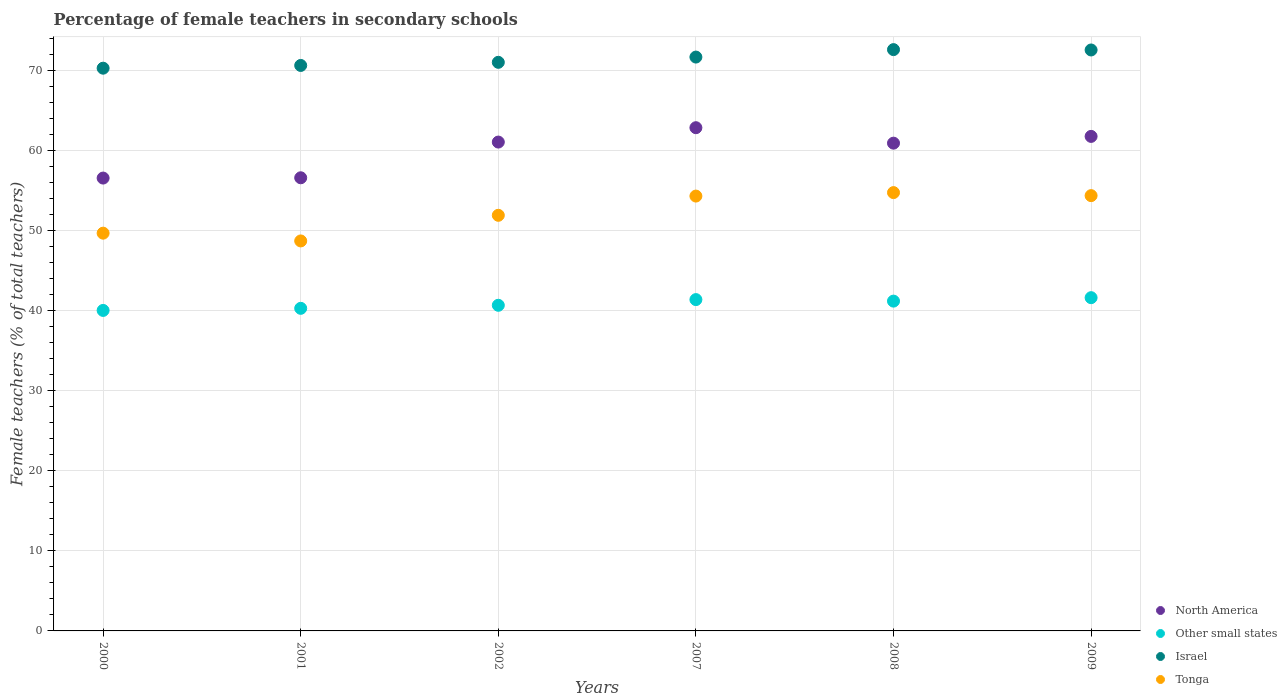How many different coloured dotlines are there?
Make the answer very short. 4. What is the percentage of female teachers in Israel in 2007?
Your response must be concise. 71.63. Across all years, what is the maximum percentage of female teachers in North America?
Give a very brief answer. 62.81. Across all years, what is the minimum percentage of female teachers in Tonga?
Your answer should be compact. 48.68. What is the total percentage of female teachers in Tonga in the graph?
Provide a short and direct response. 313.52. What is the difference between the percentage of female teachers in North America in 2008 and that in 2009?
Offer a very short reply. -0.84. What is the difference between the percentage of female teachers in Other small states in 2007 and the percentage of female teachers in North America in 2008?
Provide a short and direct response. -19.53. What is the average percentage of female teachers in Israel per year?
Offer a terse response. 71.42. In the year 2002, what is the difference between the percentage of female teachers in North America and percentage of female teachers in Tonga?
Your answer should be very brief. 9.14. In how many years, is the percentage of female teachers in North America greater than 52 %?
Give a very brief answer. 6. What is the ratio of the percentage of female teachers in Tonga in 2000 to that in 2008?
Ensure brevity in your answer.  0.91. What is the difference between the highest and the second highest percentage of female teachers in Other small states?
Provide a succinct answer. 0.24. What is the difference between the highest and the lowest percentage of female teachers in North America?
Provide a succinct answer. 6.29. Is the sum of the percentage of female teachers in North America in 2007 and 2008 greater than the maximum percentage of female teachers in Israel across all years?
Your response must be concise. Yes. How many years are there in the graph?
Your answer should be compact. 6. What is the difference between two consecutive major ticks on the Y-axis?
Give a very brief answer. 10. Does the graph contain any zero values?
Ensure brevity in your answer.  No. Where does the legend appear in the graph?
Offer a terse response. Bottom right. How many legend labels are there?
Give a very brief answer. 4. How are the legend labels stacked?
Ensure brevity in your answer.  Vertical. What is the title of the graph?
Offer a very short reply. Percentage of female teachers in secondary schools. What is the label or title of the X-axis?
Give a very brief answer. Years. What is the label or title of the Y-axis?
Give a very brief answer. Female teachers (% of total teachers). What is the Female teachers (% of total teachers) in North America in 2000?
Offer a terse response. 56.52. What is the Female teachers (% of total teachers) in Other small states in 2000?
Make the answer very short. 40. What is the Female teachers (% of total teachers) of Israel in 2000?
Ensure brevity in your answer.  70.24. What is the Female teachers (% of total teachers) in Tonga in 2000?
Give a very brief answer. 49.65. What is the Female teachers (% of total teachers) in North America in 2001?
Keep it short and to the point. 56.56. What is the Female teachers (% of total teachers) of Other small states in 2001?
Your answer should be very brief. 40.27. What is the Female teachers (% of total teachers) in Israel in 2001?
Your response must be concise. 70.58. What is the Female teachers (% of total teachers) of Tonga in 2001?
Offer a terse response. 48.68. What is the Female teachers (% of total teachers) of North America in 2002?
Give a very brief answer. 61.02. What is the Female teachers (% of total teachers) in Other small states in 2002?
Keep it short and to the point. 40.65. What is the Female teachers (% of total teachers) of Israel in 2002?
Your answer should be very brief. 70.97. What is the Female teachers (% of total teachers) in Tonga in 2002?
Your response must be concise. 51.88. What is the Female teachers (% of total teachers) in North America in 2007?
Keep it short and to the point. 62.81. What is the Female teachers (% of total teachers) of Other small states in 2007?
Your answer should be compact. 41.36. What is the Female teachers (% of total teachers) of Israel in 2007?
Keep it short and to the point. 71.63. What is the Female teachers (% of total teachers) in Tonga in 2007?
Ensure brevity in your answer.  54.28. What is the Female teachers (% of total teachers) in North America in 2008?
Your response must be concise. 60.88. What is the Female teachers (% of total teachers) of Other small states in 2008?
Keep it short and to the point. 41.17. What is the Female teachers (% of total teachers) of Israel in 2008?
Provide a short and direct response. 72.56. What is the Female teachers (% of total teachers) of Tonga in 2008?
Keep it short and to the point. 54.71. What is the Female teachers (% of total teachers) of North America in 2009?
Offer a very short reply. 61.73. What is the Female teachers (% of total teachers) in Other small states in 2009?
Offer a terse response. 41.6. What is the Female teachers (% of total teachers) of Israel in 2009?
Your answer should be very brief. 72.51. What is the Female teachers (% of total teachers) of Tonga in 2009?
Your response must be concise. 54.33. Across all years, what is the maximum Female teachers (% of total teachers) of North America?
Provide a short and direct response. 62.81. Across all years, what is the maximum Female teachers (% of total teachers) in Other small states?
Make the answer very short. 41.6. Across all years, what is the maximum Female teachers (% of total teachers) in Israel?
Provide a short and direct response. 72.56. Across all years, what is the maximum Female teachers (% of total teachers) in Tonga?
Your response must be concise. 54.71. Across all years, what is the minimum Female teachers (% of total teachers) in North America?
Offer a very short reply. 56.52. Across all years, what is the minimum Female teachers (% of total teachers) in Other small states?
Provide a succinct answer. 40. Across all years, what is the minimum Female teachers (% of total teachers) of Israel?
Provide a short and direct response. 70.24. Across all years, what is the minimum Female teachers (% of total teachers) of Tonga?
Offer a very short reply. 48.68. What is the total Female teachers (% of total teachers) in North America in the graph?
Your answer should be compact. 359.53. What is the total Female teachers (% of total teachers) of Other small states in the graph?
Ensure brevity in your answer.  245.03. What is the total Female teachers (% of total teachers) in Israel in the graph?
Your answer should be compact. 428.49. What is the total Female teachers (% of total teachers) of Tonga in the graph?
Ensure brevity in your answer.  313.52. What is the difference between the Female teachers (% of total teachers) in North America in 2000 and that in 2001?
Make the answer very short. -0.04. What is the difference between the Female teachers (% of total teachers) of Other small states in 2000 and that in 2001?
Give a very brief answer. -0.26. What is the difference between the Female teachers (% of total teachers) of Israel in 2000 and that in 2001?
Your answer should be compact. -0.34. What is the difference between the Female teachers (% of total teachers) in Tonga in 2000 and that in 2001?
Your response must be concise. 0.97. What is the difference between the Female teachers (% of total teachers) of North America in 2000 and that in 2002?
Provide a short and direct response. -4.49. What is the difference between the Female teachers (% of total teachers) of Other small states in 2000 and that in 2002?
Your answer should be compact. -0.64. What is the difference between the Female teachers (% of total teachers) in Israel in 2000 and that in 2002?
Ensure brevity in your answer.  -0.73. What is the difference between the Female teachers (% of total teachers) in Tonga in 2000 and that in 2002?
Make the answer very short. -2.23. What is the difference between the Female teachers (% of total teachers) in North America in 2000 and that in 2007?
Offer a very short reply. -6.29. What is the difference between the Female teachers (% of total teachers) in Other small states in 2000 and that in 2007?
Ensure brevity in your answer.  -1.35. What is the difference between the Female teachers (% of total teachers) of Israel in 2000 and that in 2007?
Ensure brevity in your answer.  -1.39. What is the difference between the Female teachers (% of total teachers) of Tonga in 2000 and that in 2007?
Ensure brevity in your answer.  -4.63. What is the difference between the Female teachers (% of total teachers) of North America in 2000 and that in 2008?
Give a very brief answer. -4.36. What is the difference between the Female teachers (% of total teachers) in Other small states in 2000 and that in 2008?
Offer a terse response. -1.16. What is the difference between the Female teachers (% of total teachers) in Israel in 2000 and that in 2008?
Keep it short and to the point. -2.32. What is the difference between the Female teachers (% of total teachers) in Tonga in 2000 and that in 2008?
Offer a terse response. -5.06. What is the difference between the Female teachers (% of total teachers) in North America in 2000 and that in 2009?
Offer a very short reply. -5.2. What is the difference between the Female teachers (% of total teachers) of Other small states in 2000 and that in 2009?
Offer a very short reply. -1.59. What is the difference between the Female teachers (% of total teachers) of Israel in 2000 and that in 2009?
Offer a very short reply. -2.27. What is the difference between the Female teachers (% of total teachers) in Tonga in 2000 and that in 2009?
Keep it short and to the point. -4.68. What is the difference between the Female teachers (% of total teachers) in North America in 2001 and that in 2002?
Provide a succinct answer. -4.46. What is the difference between the Female teachers (% of total teachers) in Other small states in 2001 and that in 2002?
Keep it short and to the point. -0.38. What is the difference between the Female teachers (% of total teachers) of Israel in 2001 and that in 2002?
Your answer should be very brief. -0.39. What is the difference between the Female teachers (% of total teachers) in Tonga in 2001 and that in 2002?
Provide a short and direct response. -3.2. What is the difference between the Female teachers (% of total teachers) of North America in 2001 and that in 2007?
Keep it short and to the point. -6.25. What is the difference between the Female teachers (% of total teachers) in Other small states in 2001 and that in 2007?
Ensure brevity in your answer.  -1.09. What is the difference between the Female teachers (% of total teachers) of Israel in 2001 and that in 2007?
Keep it short and to the point. -1.05. What is the difference between the Female teachers (% of total teachers) in Tonga in 2001 and that in 2007?
Provide a succinct answer. -5.6. What is the difference between the Female teachers (% of total teachers) in North America in 2001 and that in 2008?
Your answer should be compact. -4.32. What is the difference between the Female teachers (% of total teachers) in Other small states in 2001 and that in 2008?
Provide a short and direct response. -0.9. What is the difference between the Female teachers (% of total teachers) of Israel in 2001 and that in 2008?
Provide a short and direct response. -1.98. What is the difference between the Female teachers (% of total teachers) of Tonga in 2001 and that in 2008?
Give a very brief answer. -6.03. What is the difference between the Female teachers (% of total teachers) in North America in 2001 and that in 2009?
Give a very brief answer. -5.17. What is the difference between the Female teachers (% of total teachers) in Other small states in 2001 and that in 2009?
Provide a succinct answer. -1.33. What is the difference between the Female teachers (% of total teachers) of Israel in 2001 and that in 2009?
Offer a terse response. -1.93. What is the difference between the Female teachers (% of total teachers) in Tonga in 2001 and that in 2009?
Your answer should be compact. -5.65. What is the difference between the Female teachers (% of total teachers) in North America in 2002 and that in 2007?
Your response must be concise. -1.79. What is the difference between the Female teachers (% of total teachers) in Other small states in 2002 and that in 2007?
Ensure brevity in your answer.  -0.71. What is the difference between the Female teachers (% of total teachers) of Israel in 2002 and that in 2007?
Your answer should be very brief. -0.66. What is the difference between the Female teachers (% of total teachers) in Tonga in 2002 and that in 2007?
Your answer should be very brief. -2.4. What is the difference between the Female teachers (% of total teachers) of North America in 2002 and that in 2008?
Offer a very short reply. 0.14. What is the difference between the Female teachers (% of total teachers) of Other small states in 2002 and that in 2008?
Your answer should be compact. -0.52. What is the difference between the Female teachers (% of total teachers) of Israel in 2002 and that in 2008?
Offer a terse response. -1.59. What is the difference between the Female teachers (% of total teachers) of Tonga in 2002 and that in 2008?
Offer a very short reply. -2.83. What is the difference between the Female teachers (% of total teachers) of North America in 2002 and that in 2009?
Your answer should be compact. -0.71. What is the difference between the Female teachers (% of total teachers) in Other small states in 2002 and that in 2009?
Make the answer very short. -0.95. What is the difference between the Female teachers (% of total teachers) in Israel in 2002 and that in 2009?
Make the answer very short. -1.54. What is the difference between the Female teachers (% of total teachers) of Tonga in 2002 and that in 2009?
Make the answer very short. -2.45. What is the difference between the Female teachers (% of total teachers) of North America in 2007 and that in 2008?
Make the answer very short. 1.93. What is the difference between the Female teachers (% of total teachers) of Other small states in 2007 and that in 2008?
Ensure brevity in your answer.  0.19. What is the difference between the Female teachers (% of total teachers) of Israel in 2007 and that in 2008?
Make the answer very short. -0.93. What is the difference between the Female teachers (% of total teachers) in Tonga in 2007 and that in 2008?
Your answer should be compact. -0.43. What is the difference between the Female teachers (% of total teachers) of North America in 2007 and that in 2009?
Make the answer very short. 1.09. What is the difference between the Female teachers (% of total teachers) in Other small states in 2007 and that in 2009?
Ensure brevity in your answer.  -0.24. What is the difference between the Female teachers (% of total teachers) in Israel in 2007 and that in 2009?
Keep it short and to the point. -0.89. What is the difference between the Female teachers (% of total teachers) in Tonga in 2007 and that in 2009?
Offer a terse response. -0.06. What is the difference between the Female teachers (% of total teachers) of North America in 2008 and that in 2009?
Give a very brief answer. -0.84. What is the difference between the Female teachers (% of total teachers) of Other small states in 2008 and that in 2009?
Make the answer very short. -0.43. What is the difference between the Female teachers (% of total teachers) of Israel in 2008 and that in 2009?
Offer a very short reply. 0.04. What is the difference between the Female teachers (% of total teachers) of Tonga in 2008 and that in 2009?
Your response must be concise. 0.38. What is the difference between the Female teachers (% of total teachers) in North America in 2000 and the Female teachers (% of total teachers) in Other small states in 2001?
Offer a terse response. 16.26. What is the difference between the Female teachers (% of total teachers) of North America in 2000 and the Female teachers (% of total teachers) of Israel in 2001?
Offer a very short reply. -14.06. What is the difference between the Female teachers (% of total teachers) of North America in 2000 and the Female teachers (% of total teachers) of Tonga in 2001?
Ensure brevity in your answer.  7.85. What is the difference between the Female teachers (% of total teachers) in Other small states in 2000 and the Female teachers (% of total teachers) in Israel in 2001?
Your response must be concise. -30.58. What is the difference between the Female teachers (% of total teachers) in Other small states in 2000 and the Female teachers (% of total teachers) in Tonga in 2001?
Provide a succinct answer. -8.67. What is the difference between the Female teachers (% of total teachers) of Israel in 2000 and the Female teachers (% of total teachers) of Tonga in 2001?
Offer a very short reply. 21.56. What is the difference between the Female teachers (% of total teachers) in North America in 2000 and the Female teachers (% of total teachers) in Other small states in 2002?
Give a very brief answer. 15.88. What is the difference between the Female teachers (% of total teachers) in North America in 2000 and the Female teachers (% of total teachers) in Israel in 2002?
Offer a very short reply. -14.45. What is the difference between the Female teachers (% of total teachers) in North America in 2000 and the Female teachers (% of total teachers) in Tonga in 2002?
Provide a short and direct response. 4.65. What is the difference between the Female teachers (% of total teachers) in Other small states in 2000 and the Female teachers (% of total teachers) in Israel in 2002?
Offer a terse response. -30.97. What is the difference between the Female teachers (% of total teachers) of Other small states in 2000 and the Female teachers (% of total teachers) of Tonga in 2002?
Make the answer very short. -11.87. What is the difference between the Female teachers (% of total teachers) of Israel in 2000 and the Female teachers (% of total teachers) of Tonga in 2002?
Your answer should be compact. 18.36. What is the difference between the Female teachers (% of total teachers) in North America in 2000 and the Female teachers (% of total teachers) in Other small states in 2007?
Your answer should be very brief. 15.17. What is the difference between the Female teachers (% of total teachers) in North America in 2000 and the Female teachers (% of total teachers) in Israel in 2007?
Offer a terse response. -15.1. What is the difference between the Female teachers (% of total teachers) in North America in 2000 and the Female teachers (% of total teachers) in Tonga in 2007?
Provide a succinct answer. 2.25. What is the difference between the Female teachers (% of total teachers) in Other small states in 2000 and the Female teachers (% of total teachers) in Israel in 2007?
Offer a very short reply. -31.62. What is the difference between the Female teachers (% of total teachers) of Other small states in 2000 and the Female teachers (% of total teachers) of Tonga in 2007?
Provide a short and direct response. -14.27. What is the difference between the Female teachers (% of total teachers) in Israel in 2000 and the Female teachers (% of total teachers) in Tonga in 2007?
Your answer should be very brief. 15.96. What is the difference between the Female teachers (% of total teachers) in North America in 2000 and the Female teachers (% of total teachers) in Other small states in 2008?
Your answer should be very brief. 15.36. What is the difference between the Female teachers (% of total teachers) in North America in 2000 and the Female teachers (% of total teachers) in Israel in 2008?
Keep it short and to the point. -16.03. What is the difference between the Female teachers (% of total teachers) in North America in 2000 and the Female teachers (% of total teachers) in Tonga in 2008?
Your answer should be compact. 1.81. What is the difference between the Female teachers (% of total teachers) of Other small states in 2000 and the Female teachers (% of total teachers) of Israel in 2008?
Give a very brief answer. -32.55. What is the difference between the Female teachers (% of total teachers) of Other small states in 2000 and the Female teachers (% of total teachers) of Tonga in 2008?
Make the answer very short. -14.71. What is the difference between the Female teachers (% of total teachers) of Israel in 2000 and the Female teachers (% of total teachers) of Tonga in 2008?
Provide a succinct answer. 15.53. What is the difference between the Female teachers (% of total teachers) of North America in 2000 and the Female teachers (% of total teachers) of Other small states in 2009?
Ensure brevity in your answer.  14.93. What is the difference between the Female teachers (% of total teachers) in North America in 2000 and the Female teachers (% of total teachers) in Israel in 2009?
Provide a succinct answer. -15.99. What is the difference between the Female teachers (% of total teachers) in North America in 2000 and the Female teachers (% of total teachers) in Tonga in 2009?
Keep it short and to the point. 2.19. What is the difference between the Female teachers (% of total teachers) in Other small states in 2000 and the Female teachers (% of total teachers) in Israel in 2009?
Give a very brief answer. -32.51. What is the difference between the Female teachers (% of total teachers) in Other small states in 2000 and the Female teachers (% of total teachers) in Tonga in 2009?
Offer a terse response. -14.33. What is the difference between the Female teachers (% of total teachers) in Israel in 2000 and the Female teachers (% of total teachers) in Tonga in 2009?
Your answer should be compact. 15.91. What is the difference between the Female teachers (% of total teachers) in North America in 2001 and the Female teachers (% of total teachers) in Other small states in 2002?
Your answer should be very brief. 15.92. What is the difference between the Female teachers (% of total teachers) of North America in 2001 and the Female teachers (% of total teachers) of Israel in 2002?
Offer a very short reply. -14.41. What is the difference between the Female teachers (% of total teachers) in North America in 2001 and the Female teachers (% of total teachers) in Tonga in 2002?
Offer a very short reply. 4.68. What is the difference between the Female teachers (% of total teachers) of Other small states in 2001 and the Female teachers (% of total teachers) of Israel in 2002?
Ensure brevity in your answer.  -30.71. What is the difference between the Female teachers (% of total teachers) of Other small states in 2001 and the Female teachers (% of total teachers) of Tonga in 2002?
Provide a succinct answer. -11.61. What is the difference between the Female teachers (% of total teachers) of Israel in 2001 and the Female teachers (% of total teachers) of Tonga in 2002?
Your answer should be compact. 18.7. What is the difference between the Female teachers (% of total teachers) in North America in 2001 and the Female teachers (% of total teachers) in Other small states in 2007?
Your answer should be very brief. 15.21. What is the difference between the Female teachers (% of total teachers) in North America in 2001 and the Female teachers (% of total teachers) in Israel in 2007?
Your response must be concise. -15.07. What is the difference between the Female teachers (% of total teachers) in North America in 2001 and the Female teachers (% of total teachers) in Tonga in 2007?
Offer a very short reply. 2.28. What is the difference between the Female teachers (% of total teachers) in Other small states in 2001 and the Female teachers (% of total teachers) in Israel in 2007?
Offer a terse response. -31.36. What is the difference between the Female teachers (% of total teachers) of Other small states in 2001 and the Female teachers (% of total teachers) of Tonga in 2007?
Give a very brief answer. -14.01. What is the difference between the Female teachers (% of total teachers) in Israel in 2001 and the Female teachers (% of total teachers) in Tonga in 2007?
Give a very brief answer. 16.3. What is the difference between the Female teachers (% of total teachers) of North America in 2001 and the Female teachers (% of total teachers) of Other small states in 2008?
Offer a terse response. 15.39. What is the difference between the Female teachers (% of total teachers) of North America in 2001 and the Female teachers (% of total teachers) of Israel in 2008?
Your answer should be very brief. -16. What is the difference between the Female teachers (% of total teachers) in North America in 2001 and the Female teachers (% of total teachers) in Tonga in 2008?
Keep it short and to the point. 1.85. What is the difference between the Female teachers (% of total teachers) of Other small states in 2001 and the Female teachers (% of total teachers) of Israel in 2008?
Your answer should be compact. -32.29. What is the difference between the Female teachers (% of total teachers) of Other small states in 2001 and the Female teachers (% of total teachers) of Tonga in 2008?
Keep it short and to the point. -14.45. What is the difference between the Female teachers (% of total teachers) of Israel in 2001 and the Female teachers (% of total teachers) of Tonga in 2008?
Your answer should be very brief. 15.87. What is the difference between the Female teachers (% of total teachers) of North America in 2001 and the Female teachers (% of total teachers) of Other small states in 2009?
Ensure brevity in your answer.  14.96. What is the difference between the Female teachers (% of total teachers) of North America in 2001 and the Female teachers (% of total teachers) of Israel in 2009?
Offer a terse response. -15.95. What is the difference between the Female teachers (% of total teachers) in North America in 2001 and the Female teachers (% of total teachers) in Tonga in 2009?
Give a very brief answer. 2.23. What is the difference between the Female teachers (% of total teachers) of Other small states in 2001 and the Female teachers (% of total teachers) of Israel in 2009?
Ensure brevity in your answer.  -32.25. What is the difference between the Female teachers (% of total teachers) in Other small states in 2001 and the Female teachers (% of total teachers) in Tonga in 2009?
Make the answer very short. -14.07. What is the difference between the Female teachers (% of total teachers) of Israel in 2001 and the Female teachers (% of total teachers) of Tonga in 2009?
Offer a terse response. 16.25. What is the difference between the Female teachers (% of total teachers) of North America in 2002 and the Female teachers (% of total teachers) of Other small states in 2007?
Give a very brief answer. 19.66. What is the difference between the Female teachers (% of total teachers) in North America in 2002 and the Female teachers (% of total teachers) in Israel in 2007?
Offer a very short reply. -10.61. What is the difference between the Female teachers (% of total teachers) of North America in 2002 and the Female teachers (% of total teachers) of Tonga in 2007?
Offer a very short reply. 6.74. What is the difference between the Female teachers (% of total teachers) of Other small states in 2002 and the Female teachers (% of total teachers) of Israel in 2007?
Provide a succinct answer. -30.98. What is the difference between the Female teachers (% of total teachers) of Other small states in 2002 and the Female teachers (% of total teachers) of Tonga in 2007?
Keep it short and to the point. -13.63. What is the difference between the Female teachers (% of total teachers) in Israel in 2002 and the Female teachers (% of total teachers) in Tonga in 2007?
Your answer should be compact. 16.7. What is the difference between the Female teachers (% of total teachers) of North America in 2002 and the Female teachers (% of total teachers) of Other small states in 2008?
Offer a terse response. 19.85. What is the difference between the Female teachers (% of total teachers) of North America in 2002 and the Female teachers (% of total teachers) of Israel in 2008?
Provide a short and direct response. -11.54. What is the difference between the Female teachers (% of total teachers) in North America in 2002 and the Female teachers (% of total teachers) in Tonga in 2008?
Keep it short and to the point. 6.31. What is the difference between the Female teachers (% of total teachers) of Other small states in 2002 and the Female teachers (% of total teachers) of Israel in 2008?
Ensure brevity in your answer.  -31.91. What is the difference between the Female teachers (% of total teachers) in Other small states in 2002 and the Female teachers (% of total teachers) in Tonga in 2008?
Make the answer very short. -14.07. What is the difference between the Female teachers (% of total teachers) in Israel in 2002 and the Female teachers (% of total teachers) in Tonga in 2008?
Your answer should be compact. 16.26. What is the difference between the Female teachers (% of total teachers) in North America in 2002 and the Female teachers (% of total teachers) in Other small states in 2009?
Keep it short and to the point. 19.42. What is the difference between the Female teachers (% of total teachers) of North America in 2002 and the Female teachers (% of total teachers) of Israel in 2009?
Offer a terse response. -11.5. What is the difference between the Female teachers (% of total teachers) of North America in 2002 and the Female teachers (% of total teachers) of Tonga in 2009?
Your answer should be very brief. 6.69. What is the difference between the Female teachers (% of total teachers) in Other small states in 2002 and the Female teachers (% of total teachers) in Israel in 2009?
Provide a short and direct response. -31.87. What is the difference between the Female teachers (% of total teachers) in Other small states in 2002 and the Female teachers (% of total teachers) in Tonga in 2009?
Your answer should be compact. -13.69. What is the difference between the Female teachers (% of total teachers) of Israel in 2002 and the Female teachers (% of total teachers) of Tonga in 2009?
Provide a succinct answer. 16.64. What is the difference between the Female teachers (% of total teachers) in North America in 2007 and the Female teachers (% of total teachers) in Other small states in 2008?
Give a very brief answer. 21.65. What is the difference between the Female teachers (% of total teachers) in North America in 2007 and the Female teachers (% of total teachers) in Israel in 2008?
Ensure brevity in your answer.  -9.75. What is the difference between the Female teachers (% of total teachers) in North America in 2007 and the Female teachers (% of total teachers) in Tonga in 2008?
Your response must be concise. 8.1. What is the difference between the Female teachers (% of total teachers) of Other small states in 2007 and the Female teachers (% of total teachers) of Israel in 2008?
Make the answer very short. -31.2. What is the difference between the Female teachers (% of total teachers) of Other small states in 2007 and the Female teachers (% of total teachers) of Tonga in 2008?
Offer a very short reply. -13.36. What is the difference between the Female teachers (% of total teachers) in Israel in 2007 and the Female teachers (% of total teachers) in Tonga in 2008?
Make the answer very short. 16.92. What is the difference between the Female teachers (% of total teachers) in North America in 2007 and the Female teachers (% of total teachers) in Other small states in 2009?
Keep it short and to the point. 21.22. What is the difference between the Female teachers (% of total teachers) of North America in 2007 and the Female teachers (% of total teachers) of Israel in 2009?
Provide a short and direct response. -9.7. What is the difference between the Female teachers (% of total teachers) of North America in 2007 and the Female teachers (% of total teachers) of Tonga in 2009?
Provide a succinct answer. 8.48. What is the difference between the Female teachers (% of total teachers) of Other small states in 2007 and the Female teachers (% of total teachers) of Israel in 2009?
Give a very brief answer. -31.16. What is the difference between the Female teachers (% of total teachers) of Other small states in 2007 and the Female teachers (% of total teachers) of Tonga in 2009?
Your response must be concise. -12.98. What is the difference between the Female teachers (% of total teachers) in Israel in 2007 and the Female teachers (% of total teachers) in Tonga in 2009?
Provide a succinct answer. 17.29. What is the difference between the Female teachers (% of total teachers) in North America in 2008 and the Female teachers (% of total teachers) in Other small states in 2009?
Offer a terse response. 19.29. What is the difference between the Female teachers (% of total teachers) of North America in 2008 and the Female teachers (% of total teachers) of Israel in 2009?
Ensure brevity in your answer.  -11.63. What is the difference between the Female teachers (% of total teachers) in North America in 2008 and the Female teachers (% of total teachers) in Tonga in 2009?
Provide a succinct answer. 6.55. What is the difference between the Female teachers (% of total teachers) in Other small states in 2008 and the Female teachers (% of total teachers) in Israel in 2009?
Provide a short and direct response. -31.35. What is the difference between the Female teachers (% of total teachers) in Other small states in 2008 and the Female teachers (% of total teachers) in Tonga in 2009?
Ensure brevity in your answer.  -13.17. What is the difference between the Female teachers (% of total teachers) in Israel in 2008 and the Female teachers (% of total teachers) in Tonga in 2009?
Offer a terse response. 18.23. What is the average Female teachers (% of total teachers) of North America per year?
Give a very brief answer. 59.92. What is the average Female teachers (% of total teachers) in Other small states per year?
Ensure brevity in your answer.  40.84. What is the average Female teachers (% of total teachers) in Israel per year?
Ensure brevity in your answer.  71.42. What is the average Female teachers (% of total teachers) of Tonga per year?
Your response must be concise. 52.25. In the year 2000, what is the difference between the Female teachers (% of total teachers) in North America and Female teachers (% of total teachers) in Other small states?
Offer a terse response. 16.52. In the year 2000, what is the difference between the Female teachers (% of total teachers) in North America and Female teachers (% of total teachers) in Israel?
Offer a very short reply. -13.72. In the year 2000, what is the difference between the Female teachers (% of total teachers) of North America and Female teachers (% of total teachers) of Tonga?
Your response must be concise. 6.88. In the year 2000, what is the difference between the Female teachers (% of total teachers) in Other small states and Female teachers (% of total teachers) in Israel?
Provide a succinct answer. -30.24. In the year 2000, what is the difference between the Female teachers (% of total teachers) in Other small states and Female teachers (% of total teachers) in Tonga?
Offer a very short reply. -9.64. In the year 2000, what is the difference between the Female teachers (% of total teachers) of Israel and Female teachers (% of total teachers) of Tonga?
Give a very brief answer. 20.59. In the year 2001, what is the difference between the Female teachers (% of total teachers) in North America and Female teachers (% of total teachers) in Other small states?
Your answer should be very brief. 16.3. In the year 2001, what is the difference between the Female teachers (% of total teachers) of North America and Female teachers (% of total teachers) of Israel?
Your response must be concise. -14.02. In the year 2001, what is the difference between the Female teachers (% of total teachers) of North America and Female teachers (% of total teachers) of Tonga?
Offer a terse response. 7.88. In the year 2001, what is the difference between the Female teachers (% of total teachers) of Other small states and Female teachers (% of total teachers) of Israel?
Ensure brevity in your answer.  -30.32. In the year 2001, what is the difference between the Female teachers (% of total teachers) of Other small states and Female teachers (% of total teachers) of Tonga?
Make the answer very short. -8.41. In the year 2001, what is the difference between the Female teachers (% of total teachers) of Israel and Female teachers (% of total teachers) of Tonga?
Offer a terse response. 21.9. In the year 2002, what is the difference between the Female teachers (% of total teachers) in North America and Female teachers (% of total teachers) in Other small states?
Your answer should be compact. 20.37. In the year 2002, what is the difference between the Female teachers (% of total teachers) of North America and Female teachers (% of total teachers) of Israel?
Your answer should be very brief. -9.95. In the year 2002, what is the difference between the Female teachers (% of total teachers) in North America and Female teachers (% of total teachers) in Tonga?
Your response must be concise. 9.14. In the year 2002, what is the difference between the Female teachers (% of total teachers) of Other small states and Female teachers (% of total teachers) of Israel?
Make the answer very short. -30.33. In the year 2002, what is the difference between the Female teachers (% of total teachers) in Other small states and Female teachers (% of total teachers) in Tonga?
Your response must be concise. -11.23. In the year 2002, what is the difference between the Female teachers (% of total teachers) in Israel and Female teachers (% of total teachers) in Tonga?
Your answer should be very brief. 19.09. In the year 2007, what is the difference between the Female teachers (% of total teachers) in North America and Female teachers (% of total teachers) in Other small states?
Your answer should be compact. 21.46. In the year 2007, what is the difference between the Female teachers (% of total teachers) of North America and Female teachers (% of total teachers) of Israel?
Your answer should be very brief. -8.82. In the year 2007, what is the difference between the Female teachers (% of total teachers) in North America and Female teachers (% of total teachers) in Tonga?
Your answer should be very brief. 8.53. In the year 2007, what is the difference between the Female teachers (% of total teachers) of Other small states and Female teachers (% of total teachers) of Israel?
Give a very brief answer. -30.27. In the year 2007, what is the difference between the Female teachers (% of total teachers) in Other small states and Female teachers (% of total teachers) in Tonga?
Offer a terse response. -12.92. In the year 2007, what is the difference between the Female teachers (% of total teachers) of Israel and Female teachers (% of total teachers) of Tonga?
Your response must be concise. 17.35. In the year 2008, what is the difference between the Female teachers (% of total teachers) of North America and Female teachers (% of total teachers) of Other small states?
Make the answer very short. 19.72. In the year 2008, what is the difference between the Female teachers (% of total teachers) of North America and Female teachers (% of total teachers) of Israel?
Keep it short and to the point. -11.68. In the year 2008, what is the difference between the Female teachers (% of total teachers) of North America and Female teachers (% of total teachers) of Tonga?
Give a very brief answer. 6.17. In the year 2008, what is the difference between the Female teachers (% of total teachers) in Other small states and Female teachers (% of total teachers) in Israel?
Your response must be concise. -31.39. In the year 2008, what is the difference between the Female teachers (% of total teachers) of Other small states and Female teachers (% of total teachers) of Tonga?
Your response must be concise. -13.55. In the year 2008, what is the difference between the Female teachers (% of total teachers) in Israel and Female teachers (% of total teachers) in Tonga?
Your answer should be compact. 17.85. In the year 2009, what is the difference between the Female teachers (% of total teachers) of North America and Female teachers (% of total teachers) of Other small states?
Ensure brevity in your answer.  20.13. In the year 2009, what is the difference between the Female teachers (% of total teachers) of North America and Female teachers (% of total teachers) of Israel?
Your answer should be compact. -10.79. In the year 2009, what is the difference between the Female teachers (% of total teachers) of North America and Female teachers (% of total teachers) of Tonga?
Your answer should be compact. 7.39. In the year 2009, what is the difference between the Female teachers (% of total teachers) in Other small states and Female teachers (% of total teachers) in Israel?
Give a very brief answer. -30.92. In the year 2009, what is the difference between the Female teachers (% of total teachers) in Other small states and Female teachers (% of total teachers) in Tonga?
Make the answer very short. -12.74. In the year 2009, what is the difference between the Female teachers (% of total teachers) of Israel and Female teachers (% of total teachers) of Tonga?
Make the answer very short. 18.18. What is the ratio of the Female teachers (% of total teachers) in North America in 2000 to that in 2001?
Provide a succinct answer. 1. What is the ratio of the Female teachers (% of total teachers) in Other small states in 2000 to that in 2001?
Make the answer very short. 0.99. What is the ratio of the Female teachers (% of total teachers) of Tonga in 2000 to that in 2001?
Keep it short and to the point. 1.02. What is the ratio of the Female teachers (% of total teachers) in North America in 2000 to that in 2002?
Give a very brief answer. 0.93. What is the ratio of the Female teachers (% of total teachers) of Other small states in 2000 to that in 2002?
Keep it short and to the point. 0.98. What is the ratio of the Female teachers (% of total teachers) of Tonga in 2000 to that in 2002?
Make the answer very short. 0.96. What is the ratio of the Female teachers (% of total teachers) in North America in 2000 to that in 2007?
Provide a short and direct response. 0.9. What is the ratio of the Female teachers (% of total teachers) in Other small states in 2000 to that in 2007?
Give a very brief answer. 0.97. What is the ratio of the Female teachers (% of total teachers) in Israel in 2000 to that in 2007?
Make the answer very short. 0.98. What is the ratio of the Female teachers (% of total teachers) of Tonga in 2000 to that in 2007?
Your answer should be compact. 0.91. What is the ratio of the Female teachers (% of total teachers) of North America in 2000 to that in 2008?
Give a very brief answer. 0.93. What is the ratio of the Female teachers (% of total teachers) in Other small states in 2000 to that in 2008?
Ensure brevity in your answer.  0.97. What is the ratio of the Female teachers (% of total teachers) in Israel in 2000 to that in 2008?
Your response must be concise. 0.97. What is the ratio of the Female teachers (% of total teachers) in Tonga in 2000 to that in 2008?
Your response must be concise. 0.91. What is the ratio of the Female teachers (% of total teachers) of North America in 2000 to that in 2009?
Make the answer very short. 0.92. What is the ratio of the Female teachers (% of total teachers) in Other small states in 2000 to that in 2009?
Provide a succinct answer. 0.96. What is the ratio of the Female teachers (% of total teachers) in Israel in 2000 to that in 2009?
Keep it short and to the point. 0.97. What is the ratio of the Female teachers (% of total teachers) in Tonga in 2000 to that in 2009?
Your answer should be compact. 0.91. What is the ratio of the Female teachers (% of total teachers) of North America in 2001 to that in 2002?
Ensure brevity in your answer.  0.93. What is the ratio of the Female teachers (% of total teachers) of Tonga in 2001 to that in 2002?
Provide a succinct answer. 0.94. What is the ratio of the Female teachers (% of total teachers) of North America in 2001 to that in 2007?
Keep it short and to the point. 0.9. What is the ratio of the Female teachers (% of total teachers) in Other small states in 2001 to that in 2007?
Offer a very short reply. 0.97. What is the ratio of the Female teachers (% of total teachers) of Israel in 2001 to that in 2007?
Provide a short and direct response. 0.99. What is the ratio of the Female teachers (% of total teachers) in Tonga in 2001 to that in 2007?
Keep it short and to the point. 0.9. What is the ratio of the Female teachers (% of total teachers) in North America in 2001 to that in 2008?
Offer a terse response. 0.93. What is the ratio of the Female teachers (% of total teachers) in Other small states in 2001 to that in 2008?
Offer a terse response. 0.98. What is the ratio of the Female teachers (% of total teachers) in Israel in 2001 to that in 2008?
Give a very brief answer. 0.97. What is the ratio of the Female teachers (% of total teachers) in Tonga in 2001 to that in 2008?
Offer a terse response. 0.89. What is the ratio of the Female teachers (% of total teachers) in North America in 2001 to that in 2009?
Your answer should be compact. 0.92. What is the ratio of the Female teachers (% of total teachers) in Other small states in 2001 to that in 2009?
Offer a very short reply. 0.97. What is the ratio of the Female teachers (% of total teachers) in Israel in 2001 to that in 2009?
Provide a succinct answer. 0.97. What is the ratio of the Female teachers (% of total teachers) of Tonga in 2001 to that in 2009?
Ensure brevity in your answer.  0.9. What is the ratio of the Female teachers (% of total teachers) in North America in 2002 to that in 2007?
Your response must be concise. 0.97. What is the ratio of the Female teachers (% of total teachers) in Other small states in 2002 to that in 2007?
Provide a short and direct response. 0.98. What is the ratio of the Female teachers (% of total teachers) in Israel in 2002 to that in 2007?
Provide a short and direct response. 0.99. What is the ratio of the Female teachers (% of total teachers) in Tonga in 2002 to that in 2007?
Give a very brief answer. 0.96. What is the ratio of the Female teachers (% of total teachers) in Other small states in 2002 to that in 2008?
Keep it short and to the point. 0.99. What is the ratio of the Female teachers (% of total teachers) of Israel in 2002 to that in 2008?
Offer a terse response. 0.98. What is the ratio of the Female teachers (% of total teachers) in Tonga in 2002 to that in 2008?
Make the answer very short. 0.95. What is the ratio of the Female teachers (% of total teachers) in North America in 2002 to that in 2009?
Offer a very short reply. 0.99. What is the ratio of the Female teachers (% of total teachers) of Other small states in 2002 to that in 2009?
Provide a short and direct response. 0.98. What is the ratio of the Female teachers (% of total teachers) of Israel in 2002 to that in 2009?
Provide a succinct answer. 0.98. What is the ratio of the Female teachers (% of total teachers) of Tonga in 2002 to that in 2009?
Your response must be concise. 0.95. What is the ratio of the Female teachers (% of total teachers) in North America in 2007 to that in 2008?
Offer a terse response. 1.03. What is the ratio of the Female teachers (% of total teachers) of Israel in 2007 to that in 2008?
Make the answer very short. 0.99. What is the ratio of the Female teachers (% of total teachers) in Tonga in 2007 to that in 2008?
Offer a terse response. 0.99. What is the ratio of the Female teachers (% of total teachers) of North America in 2007 to that in 2009?
Make the answer very short. 1.02. What is the ratio of the Female teachers (% of total teachers) in Other small states in 2007 to that in 2009?
Provide a succinct answer. 0.99. What is the ratio of the Female teachers (% of total teachers) of Tonga in 2007 to that in 2009?
Keep it short and to the point. 1. What is the ratio of the Female teachers (% of total teachers) of North America in 2008 to that in 2009?
Your answer should be very brief. 0.99. What is the ratio of the Female teachers (% of total teachers) of Other small states in 2008 to that in 2009?
Provide a short and direct response. 0.99. What is the ratio of the Female teachers (% of total teachers) of Israel in 2008 to that in 2009?
Your response must be concise. 1. What is the difference between the highest and the second highest Female teachers (% of total teachers) in North America?
Your answer should be very brief. 1.09. What is the difference between the highest and the second highest Female teachers (% of total teachers) of Other small states?
Ensure brevity in your answer.  0.24. What is the difference between the highest and the second highest Female teachers (% of total teachers) in Israel?
Provide a succinct answer. 0.04. What is the difference between the highest and the second highest Female teachers (% of total teachers) of Tonga?
Your response must be concise. 0.38. What is the difference between the highest and the lowest Female teachers (% of total teachers) of North America?
Provide a short and direct response. 6.29. What is the difference between the highest and the lowest Female teachers (% of total teachers) in Other small states?
Your response must be concise. 1.59. What is the difference between the highest and the lowest Female teachers (% of total teachers) of Israel?
Ensure brevity in your answer.  2.32. What is the difference between the highest and the lowest Female teachers (% of total teachers) of Tonga?
Ensure brevity in your answer.  6.03. 